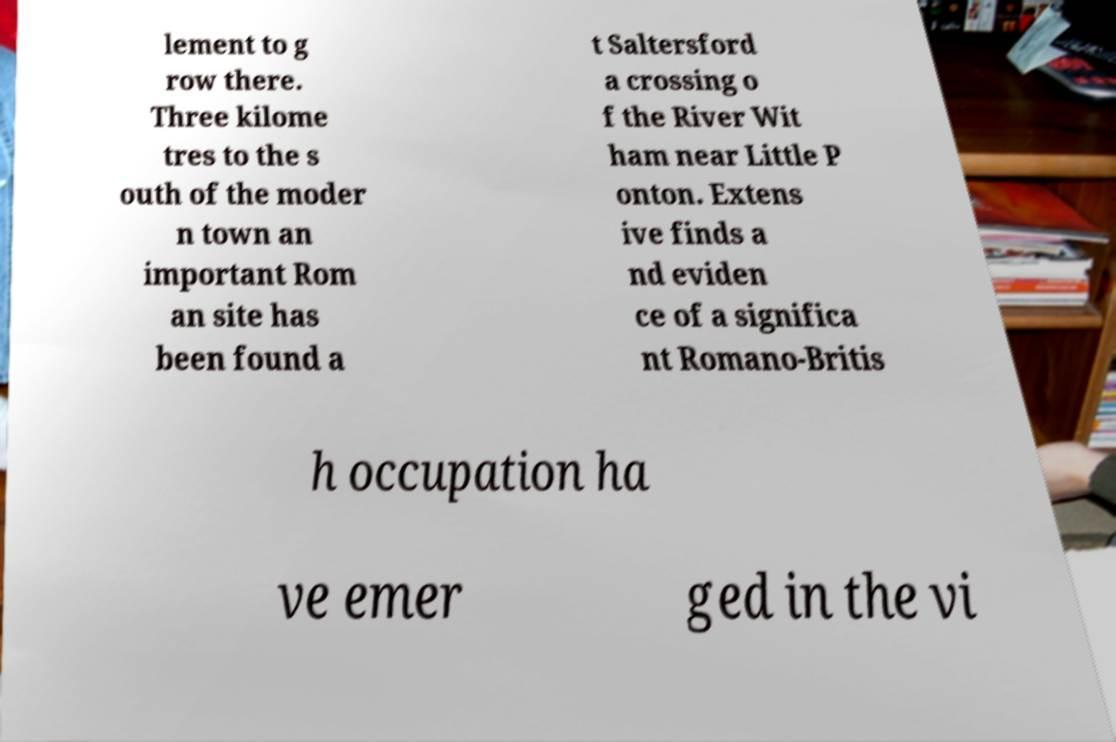I need the written content from this picture converted into text. Can you do that? lement to g row there. Three kilome tres to the s outh of the moder n town an important Rom an site has been found a t Saltersford a crossing o f the River Wit ham near Little P onton. Extens ive finds a nd eviden ce of a significa nt Romano-Britis h occupation ha ve emer ged in the vi 